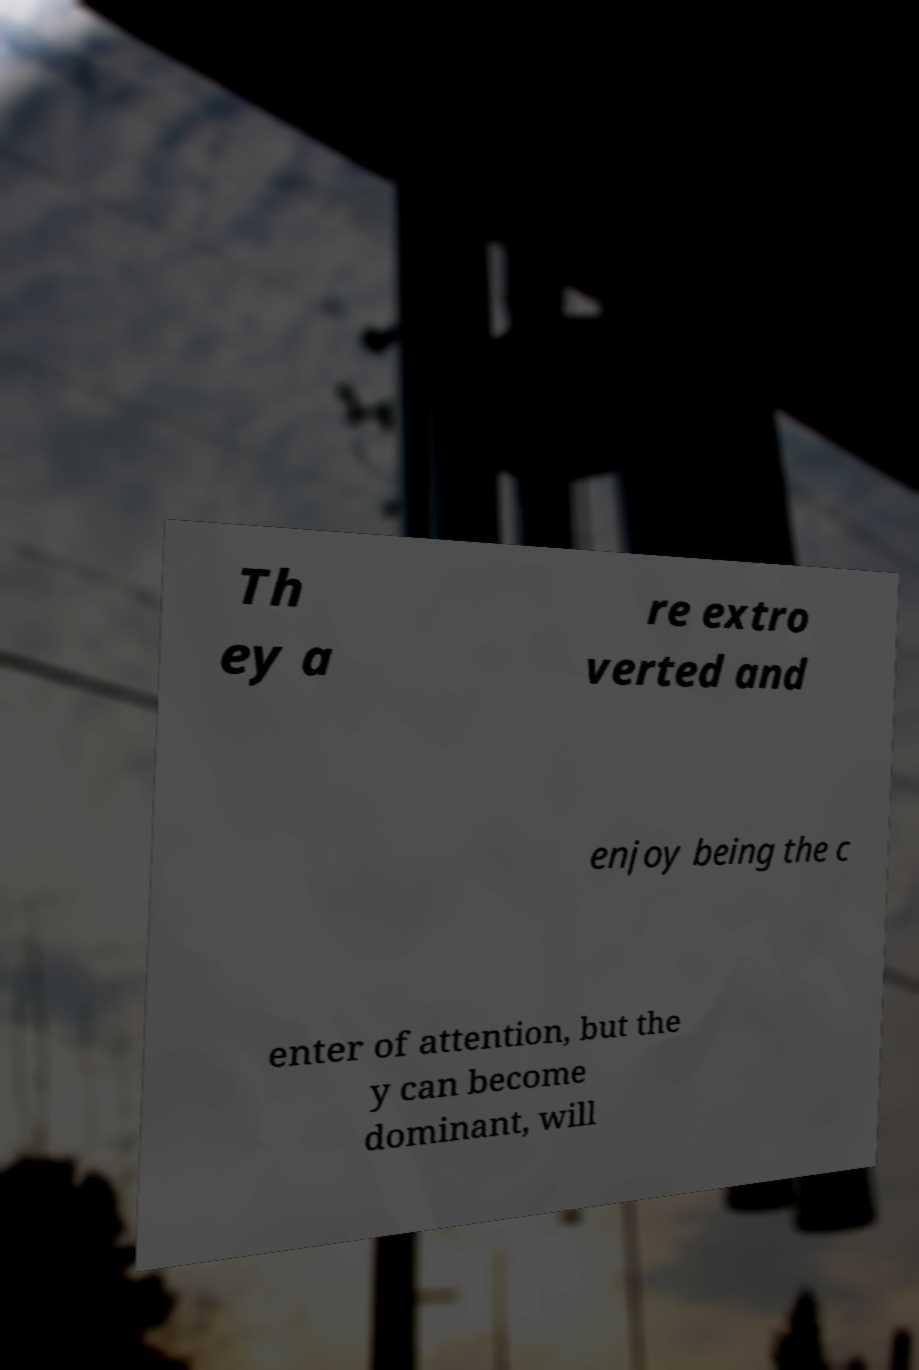Can you read and provide the text displayed in the image?This photo seems to have some interesting text. Can you extract and type it out for me? Th ey a re extro verted and enjoy being the c enter of attention, but the y can become dominant, will 